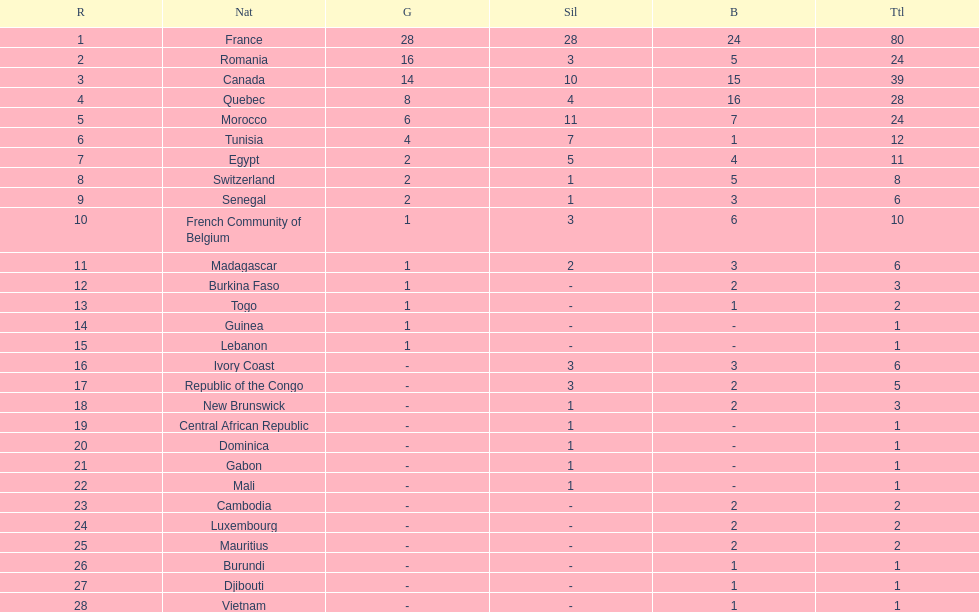How do the silver medals of france and egypt differ from each other? 23. 